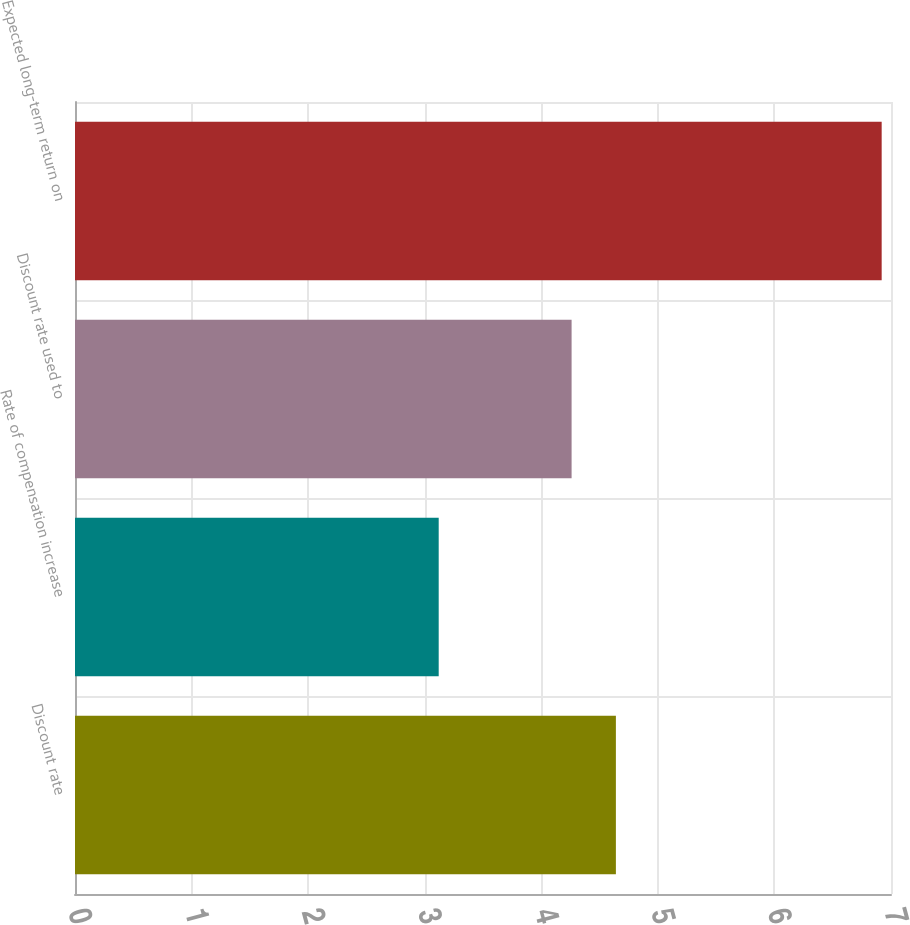Convert chart. <chart><loc_0><loc_0><loc_500><loc_500><bar_chart><fcel>Discount rate<fcel>Rate of compensation increase<fcel>Discount rate used to<fcel>Expected long-term return on<nl><fcel>4.64<fcel>3.12<fcel>4.26<fcel>6.92<nl></chart> 